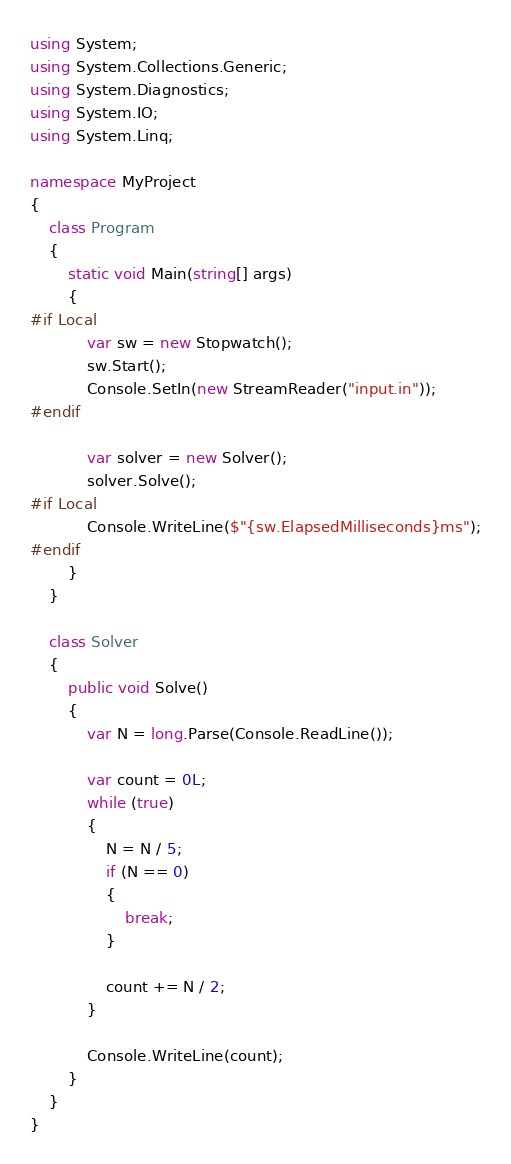<code> <loc_0><loc_0><loc_500><loc_500><_C#_>using System;
using System.Collections.Generic;
using System.Diagnostics;
using System.IO;
using System.Linq;

namespace MyProject
{
    class Program
    {
        static void Main(string[] args)
        {
#if Local
            var sw = new Stopwatch();
            sw.Start();
            Console.SetIn(new StreamReader("input.in"));
#endif

            var solver = new Solver();
            solver.Solve();
#if Local
            Console.WriteLine($"{sw.ElapsedMilliseconds}ms");
#endif
        }
    }

    class Solver
    {
        public void Solve()
        {
            var N = long.Parse(Console.ReadLine());

            var count = 0L;
            while (true)
            {
                N = N / 5;
                if (N == 0)
                {
                    break;
                }

                count += N / 2;
            }

            Console.WriteLine(count);
        }
    }
}
</code> 